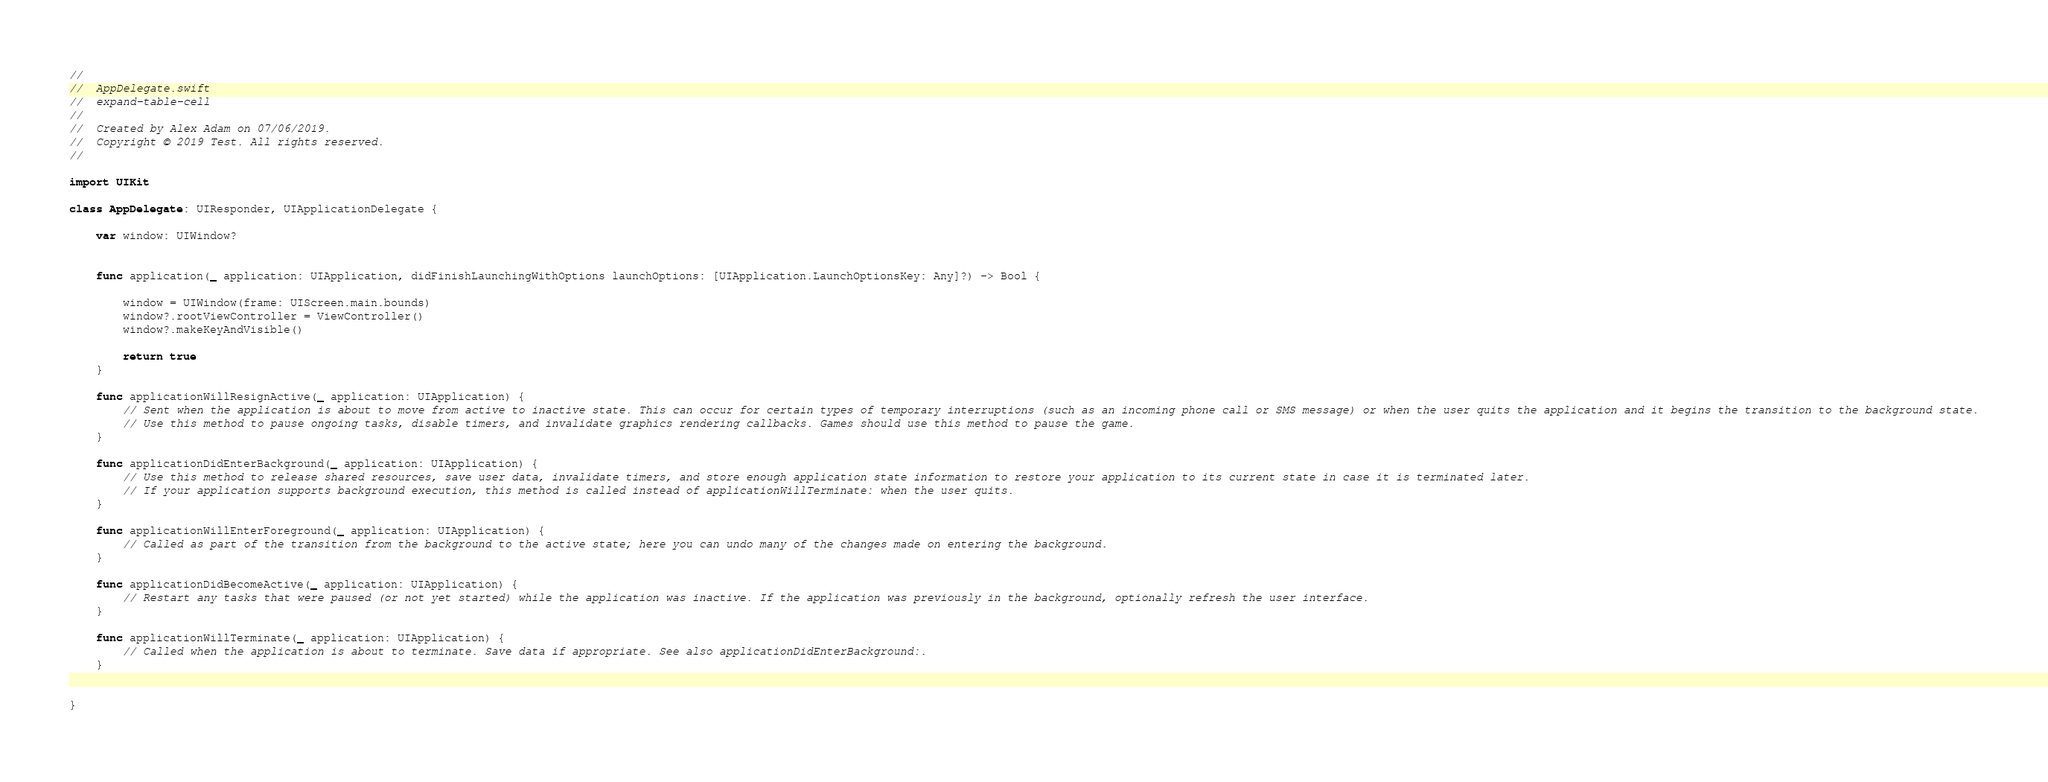Convert code to text. <code><loc_0><loc_0><loc_500><loc_500><_Swift_>//
//  AppDelegate.swift
//  expand-table-cell
//
//  Created by Alex Adam on 07/06/2019.
//  Copyright © 2019 Test. All rights reserved.
//

import UIKit

class AppDelegate: UIResponder, UIApplicationDelegate {

    var window: UIWindow?


    func application(_ application: UIApplication, didFinishLaunchingWithOptions launchOptions: [UIApplication.LaunchOptionsKey: Any]?) -> Bool {
        
        window = UIWindow(frame: UIScreen.main.bounds)
        window?.rootViewController = ViewController()
        window?.makeKeyAndVisible()
        
        return true
    }

    func applicationWillResignActive(_ application: UIApplication) {
        // Sent when the application is about to move from active to inactive state. This can occur for certain types of temporary interruptions (such as an incoming phone call or SMS message) or when the user quits the application and it begins the transition to the background state.
        // Use this method to pause ongoing tasks, disable timers, and invalidate graphics rendering callbacks. Games should use this method to pause the game.
    }

    func applicationDidEnterBackground(_ application: UIApplication) {
        // Use this method to release shared resources, save user data, invalidate timers, and store enough application state information to restore your application to its current state in case it is terminated later.
        // If your application supports background execution, this method is called instead of applicationWillTerminate: when the user quits.
    }

    func applicationWillEnterForeground(_ application: UIApplication) {
        // Called as part of the transition from the background to the active state; here you can undo many of the changes made on entering the background.
    }

    func applicationDidBecomeActive(_ application: UIApplication) {
        // Restart any tasks that were paused (or not yet started) while the application was inactive. If the application was previously in the background, optionally refresh the user interface.
    }

    func applicationWillTerminate(_ application: UIApplication) {
        // Called when the application is about to terminate. Save data if appropriate. See also applicationDidEnterBackground:.
    }


}

</code> 